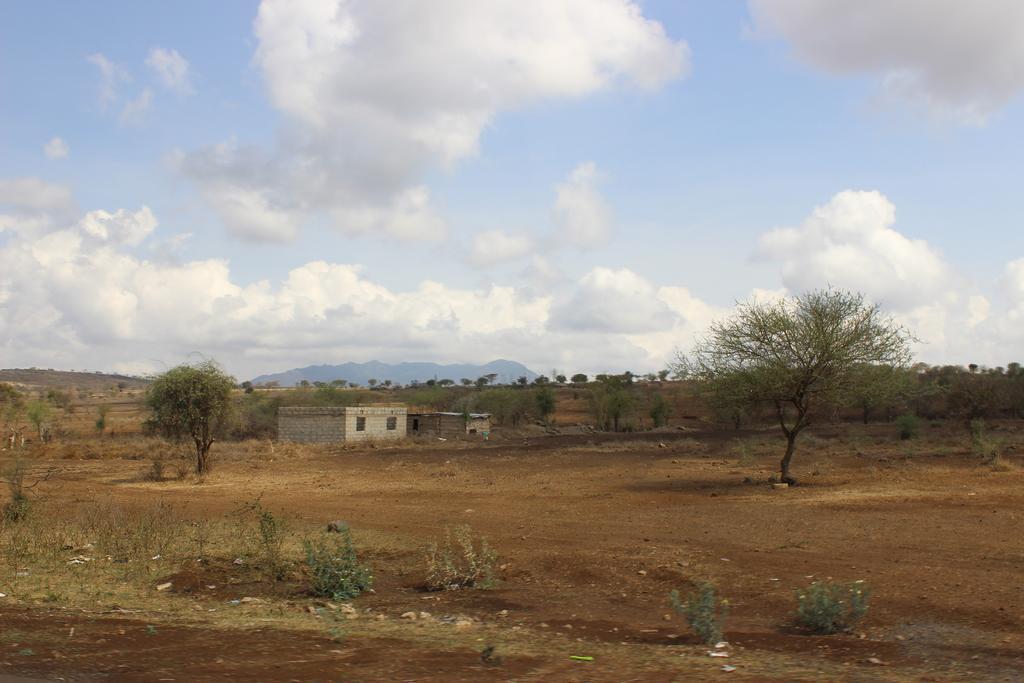Please provide a concise description of this image. In the center of the image we can see two buildings with windows. In the background, we can see a group of trees, plants, mountains and the cloudy sky. 